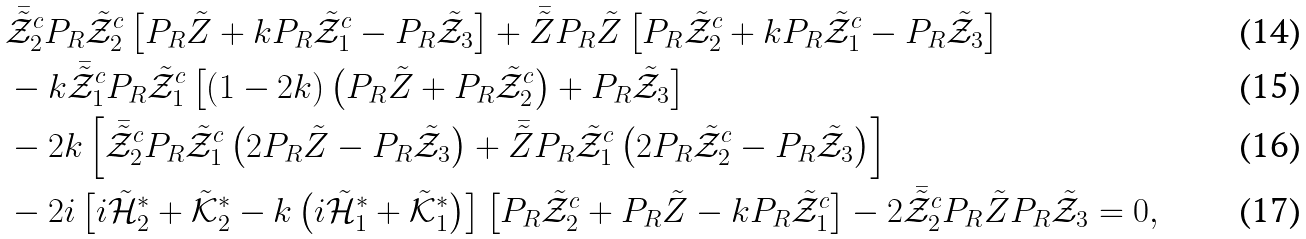<formula> <loc_0><loc_0><loc_500><loc_500>& \bar { \tilde { \mathcal { Z } } } _ { 2 } ^ { c } P _ { R } \tilde { \mathcal { Z } } _ { 2 } ^ { c } \left [ P _ { R } \tilde { Z } + k P _ { R } \tilde { \mathcal { Z } } _ { 1 } ^ { c } - P _ { R } \tilde { \mathcal { Z } } _ { 3 } \right ] + \bar { \tilde { Z } } P _ { R } \tilde { Z } \left [ P _ { R } \tilde { \mathcal { Z } } _ { 2 } ^ { c } + k P _ { R } \tilde { \mathcal { Z } } _ { 1 } ^ { c } - P _ { R } \tilde { \mathcal { Z } } _ { 3 } \right ] \\ & - k \bar { \tilde { \mathcal { Z } } } _ { 1 } ^ { c } P _ { R } \tilde { \mathcal { Z } } _ { 1 } ^ { c } \left [ \left ( 1 - 2 k \right ) \left ( P _ { R } \tilde { Z } + P _ { R } \tilde { \mathcal { Z } } _ { 2 } ^ { c } \right ) + P _ { R } \tilde { \mathcal { Z } } _ { 3 } \right ] \\ & - 2 k \left [ \bar { \tilde { \mathcal { Z } } } _ { 2 } ^ { c } P _ { R } \tilde { \mathcal { Z } } _ { 1 } ^ { c } \left ( 2 P _ { R } \tilde { Z } - P _ { R } \tilde { \mathcal { Z } } _ { 3 } \right ) + \bar { \tilde { Z } } P _ { R } \tilde { \mathcal { Z } } _ { 1 } ^ { c } \left ( 2 P _ { R } \tilde { \mathcal { Z } } _ { 2 } ^ { c } - P _ { R } \tilde { \mathcal { Z } } _ { 3 } \right ) \right ] \\ & - 2 i \left [ i \tilde { \mathcal { H } } _ { 2 } ^ { * } + \tilde { \mathcal { K } } _ { 2 } ^ { * } - k \left ( i \tilde { \mathcal { H } } _ { 1 } ^ { * } + \tilde { \mathcal { K } } _ { 1 } ^ { * } \right ) \right ] \left [ P _ { R } \tilde { \mathcal { Z } } _ { 2 } ^ { c } + P _ { R } \tilde { Z } - k P _ { R } \tilde { \mathcal { Z } } _ { 1 } ^ { c } \right ] - 2 \bar { \tilde { \mathcal { Z } } } _ { 2 } ^ { c } P _ { R } \tilde { Z } P _ { R } \tilde { \mathcal { Z } } _ { 3 } = 0 ,</formula> 